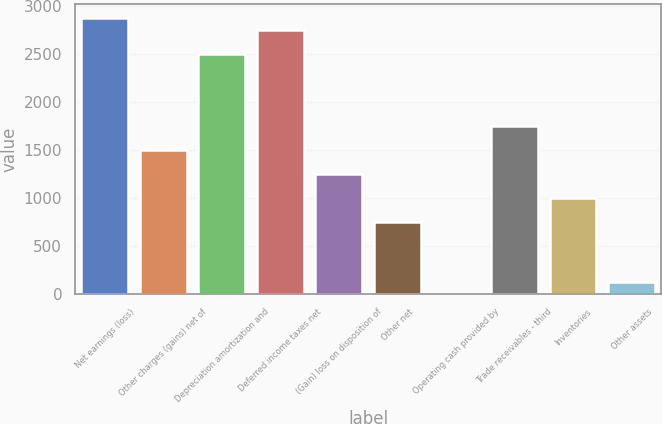<chart> <loc_0><loc_0><loc_500><loc_500><bar_chart><fcel>Net earnings (loss)<fcel>Other charges (gains) net of<fcel>Depreciation amortization and<fcel>Deferred income taxes net<fcel>(Gain) loss on disposition of<fcel>Other net<fcel>Operating cash provided by<fcel>Trade receivables - third<fcel>Inventories<fcel>Other assets<nl><fcel>2881.6<fcel>1504.4<fcel>2506<fcel>2756.4<fcel>1254<fcel>753.2<fcel>2<fcel>1754.8<fcel>1003.6<fcel>127.2<nl></chart> 